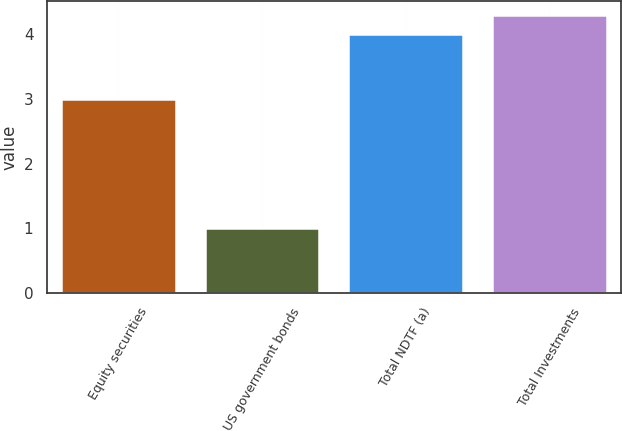<chart> <loc_0><loc_0><loc_500><loc_500><bar_chart><fcel>Equity securities<fcel>US government bonds<fcel>Total NDTF (a)<fcel>Total Investments<nl><fcel>3<fcel>1<fcel>4<fcel>4.3<nl></chart> 